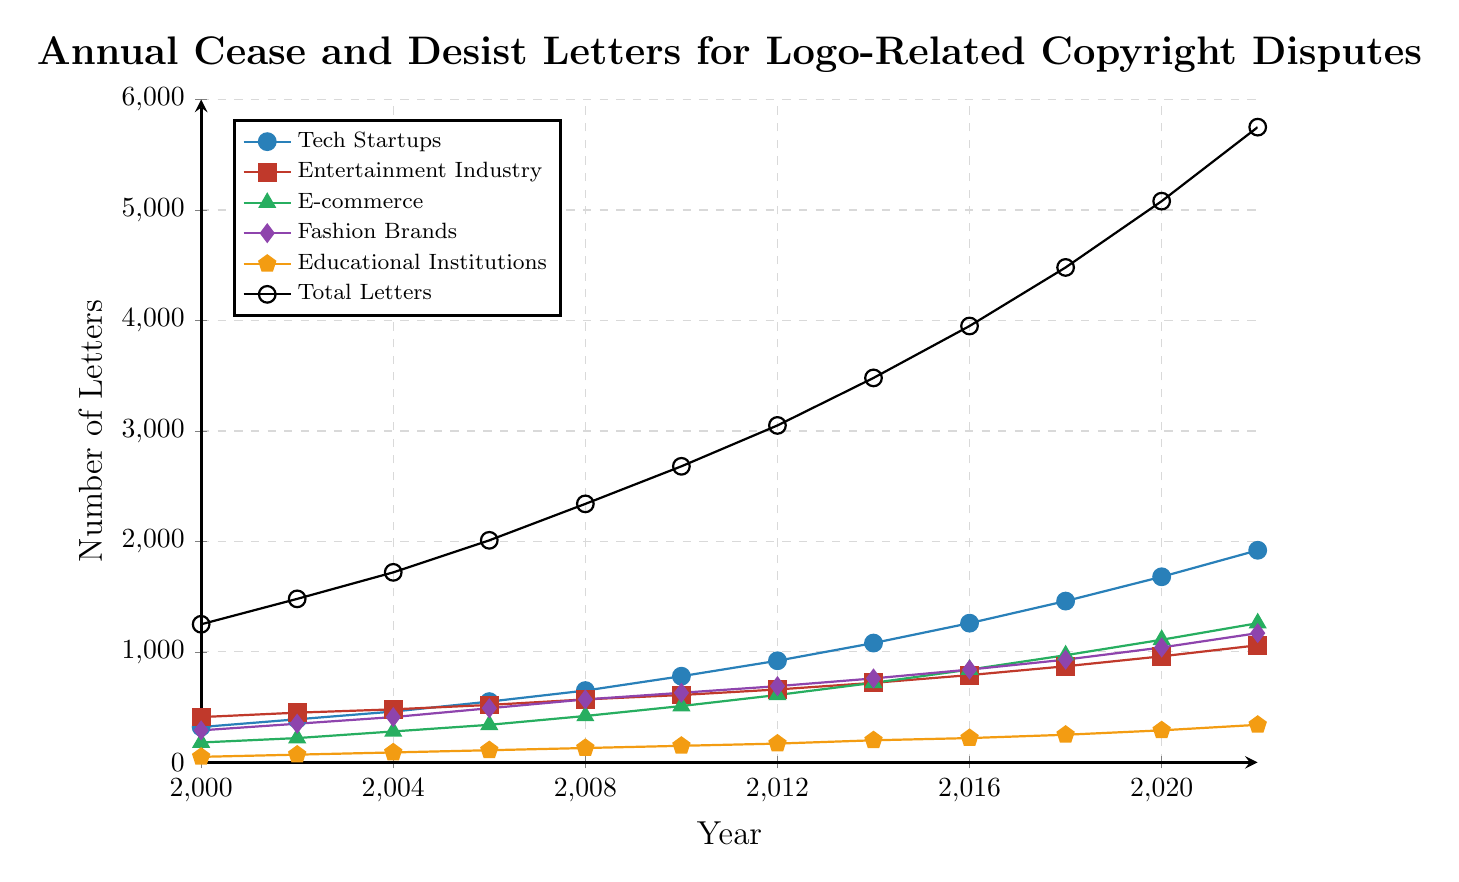Which sector had the highest number of cease and desist letters in 2018? To find this, refer to the legend to identify the colors for different sectors, then look at the data points for 2018. The sector with the highest value will match the highest y-coordinate for that year.
Answer: Tech Startups How much did the total number of letters increase from 2000 to 2022? Subtract the total number of letters in 2000 from the total number of letters in 2022: 5750 - 1250.
Answer: 4500 What's the average number of cease and desist letters sent to E-commerce per year between 2002 and 2010? Sum the values for E-commerce from 2002, 2004, 2006, 2008, and 2010, and then divide by the number of years: (220 + 280 + 340 + 420 + 510) / 5.
Answer: 354 Which sector has shown the most growth in cease and desist letters from 2000 to 2022? To compare growth, look at the starting and ending values for each sector and compute the differences: Tech Startups (1920-320=1600), Entertainment Industry (1060-410=650), E-commerce (1260-180=1080), Fashion Brands (1170-290=880), Educational Institutions (340-50=290). Tech Startups have the highest growth.
Answer: Tech Startups By how much did the number of cease and desist letters for Fashion Brands change from 2014 to 2020? Subtract the number of letters in 2014 from the number of letters in 2020: 1040 - 760.
Answer: 280 In which year did the total number of cease and desist letters first exceed 4000? Identify the year where the data point for Total Letters crosses 4000 on the y-axis. This occurs between 2014 and 2016, so 2016 is the year.
Answer: 2016 What's the difference between the highest and lowest number of cease and desist letters sent to Educational Institutions? Subtract the lowest value for Educational Institutions (50 in 2000) from the highest value (340 in 2022): 340 - 50.
Answer: 290 What was the total number of cease and desist letters sent to both Tech Startups and the Entertainment Industry in 2010? Add the numbers of letters sent to Tech Startups and the Entertainment Industry in 2010: 780 + 610.
Answer: 1390 